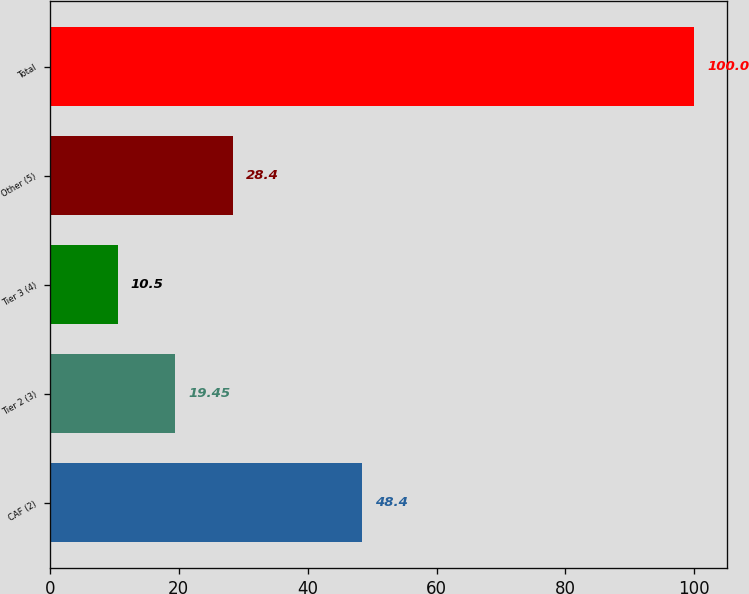Convert chart. <chart><loc_0><loc_0><loc_500><loc_500><bar_chart><fcel>CAF (2)<fcel>Tier 2 (3)<fcel>Tier 3 (4)<fcel>Other (5)<fcel>Total<nl><fcel>48.4<fcel>19.45<fcel>10.5<fcel>28.4<fcel>100<nl></chart> 